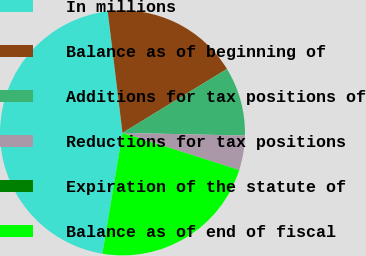Convert chart to OTSL. <chart><loc_0><loc_0><loc_500><loc_500><pie_chart><fcel>In millions<fcel>Balance as of beginning of<fcel>Additions for tax positions of<fcel>Reductions for tax positions<fcel>Expiration of the statute of<fcel>Balance as of end of fiscal<nl><fcel>45.44%<fcel>18.18%<fcel>9.09%<fcel>4.55%<fcel>0.01%<fcel>22.72%<nl></chart> 